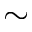<formula> <loc_0><loc_0><loc_500><loc_500>\sim</formula> 